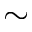<formula> <loc_0><loc_0><loc_500><loc_500>\sim</formula> 